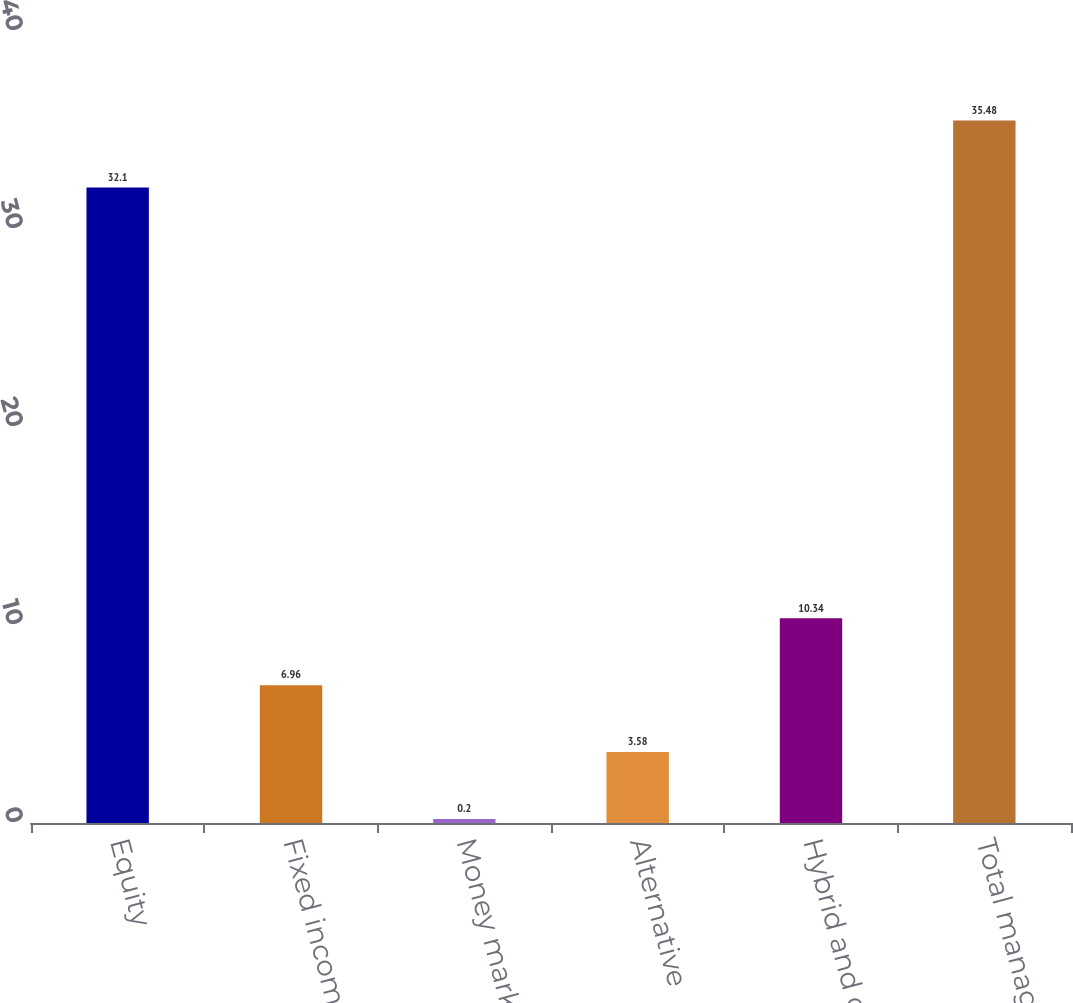Convert chart. <chart><loc_0><loc_0><loc_500><loc_500><bar_chart><fcel>Equity<fcel>Fixed income<fcel>Money market<fcel>Alternative<fcel>Hybrid and other<fcel>Total managed assets<nl><fcel>32.1<fcel>6.96<fcel>0.2<fcel>3.58<fcel>10.34<fcel>35.48<nl></chart> 